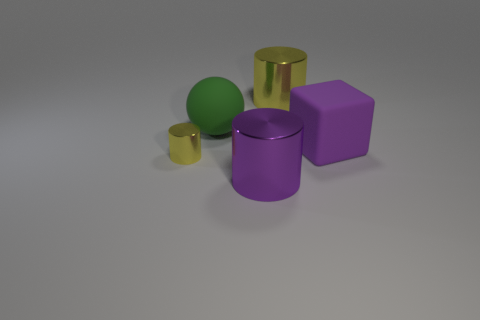The small metallic cylinder has what color? The small metallic cylinder in the image is golden in color, displaying a shiny surface that reflects light, creating highlights and shadows which contribute to the metallic effect. 